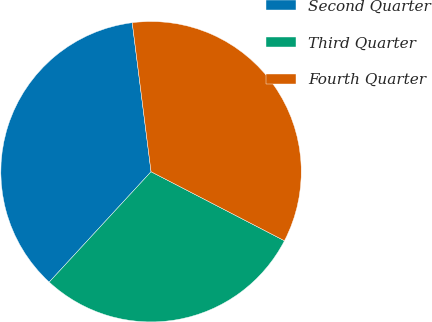Convert chart to OTSL. <chart><loc_0><loc_0><loc_500><loc_500><pie_chart><fcel>Second Quarter<fcel>Third Quarter<fcel>Fourth Quarter<nl><fcel>36.14%<fcel>29.26%<fcel>34.6%<nl></chart> 